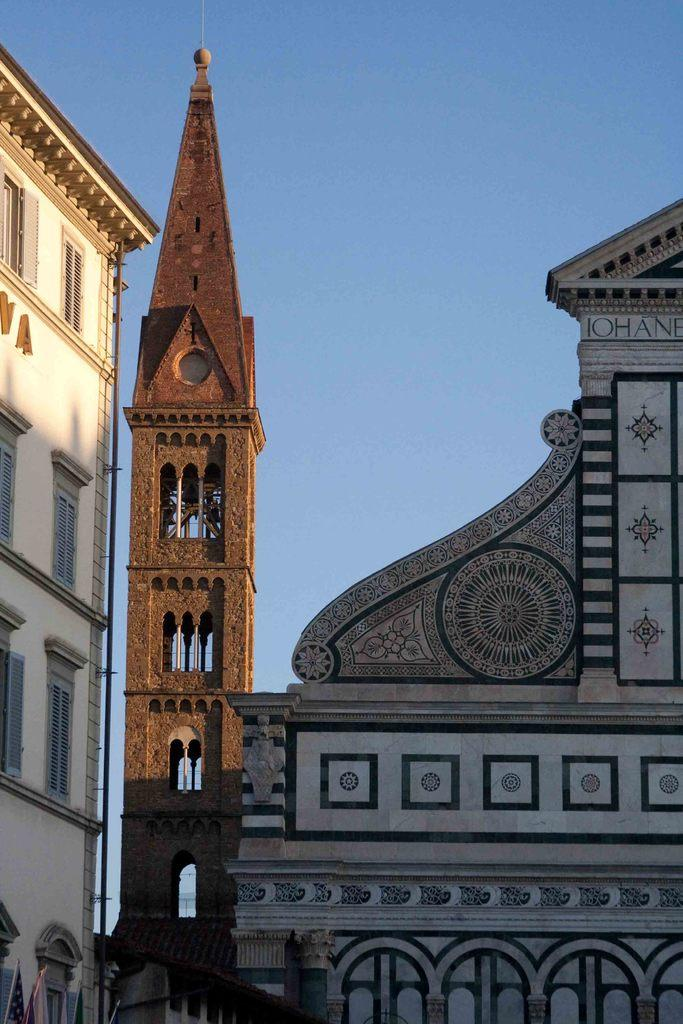What type of structures can be seen in the image? There are buildings in the image. Can you describe a specific building in the image? There is a brown-colored tower in the image. What is visible in the background of the image? The sky is visible in the background of the image. How would you describe the weather based on the sky in the image? The sky appears to be clear, suggesting good weather. How many wires are connected to the brown-colored tower in the image? There are no wires connected to the brown-colored tower in the image. What type of structure is the drop coming from in the image? There is no drop present in the image. 